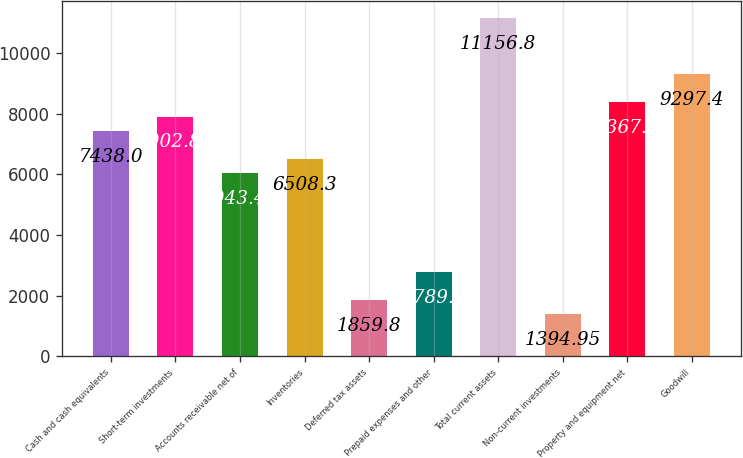Convert chart to OTSL. <chart><loc_0><loc_0><loc_500><loc_500><bar_chart><fcel>Cash and cash equivalents<fcel>Short-term investments<fcel>Accounts receivable net of<fcel>Inventories<fcel>Deferred tax assets<fcel>Prepaid expenses and other<fcel>Total current assets<fcel>Non-current investments<fcel>Property and equipment net<fcel>Goodwill<nl><fcel>7438<fcel>7902.85<fcel>6043.45<fcel>6508.3<fcel>1859.8<fcel>2789.5<fcel>11156.8<fcel>1394.95<fcel>8367.7<fcel>9297.4<nl></chart> 